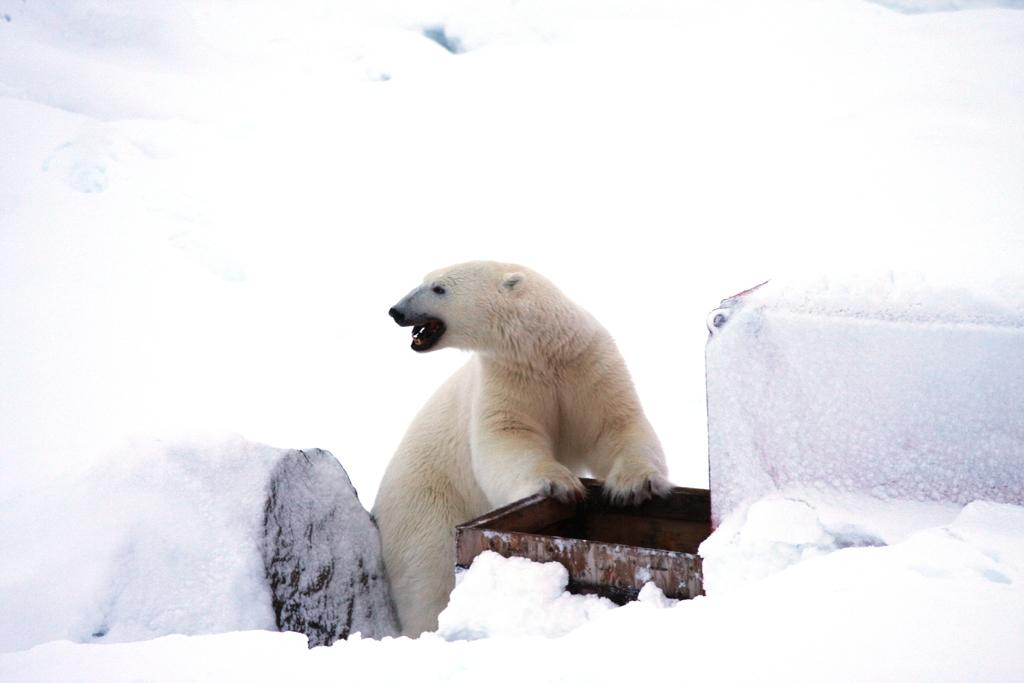What animal is located in the middle of the picture? There is a polar bear in the middle of the picture. What type of terrain is visible in the background of the image? There is snow on the land in the background of the image. Can you see any orange objects in the image? There are no orange objects present in the image. Is the polar bear stuck in quicksand in the image? There is no quicksand present in the image, and the polar bear is not shown to be stuck in any substance. 